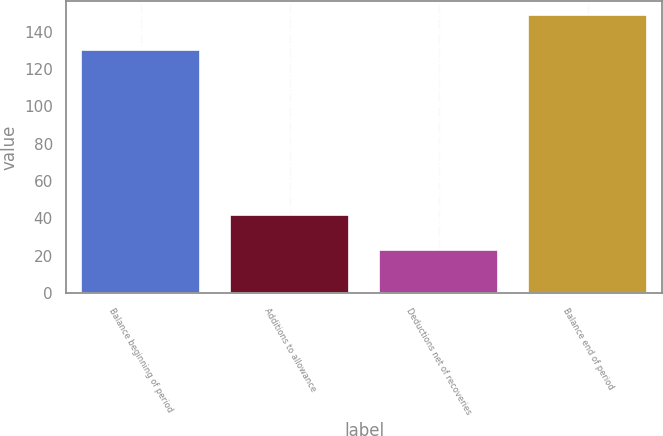<chart> <loc_0><loc_0><loc_500><loc_500><bar_chart><fcel>Balance beginning of period<fcel>Additions to allowance<fcel>Deductions net of recoveries<fcel>Balance end of period<nl><fcel>130<fcel>42<fcel>23<fcel>149<nl></chart> 